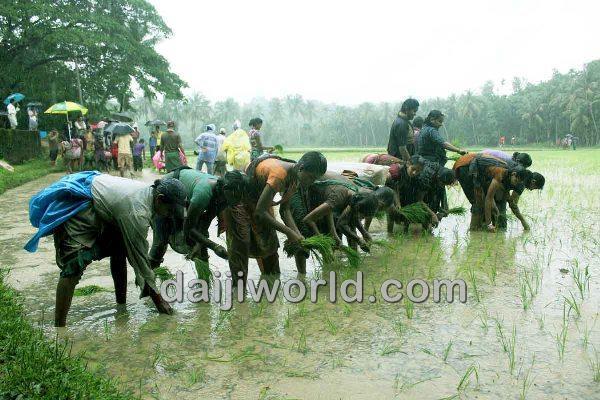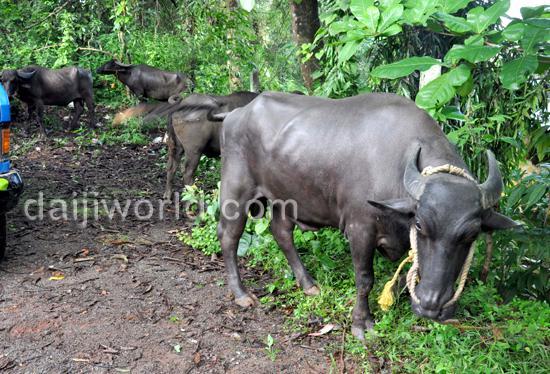The first image is the image on the left, the second image is the image on the right. Evaluate the accuracy of this statement regarding the images: "In one of the images, water buffalos are standing in muddy water.". Is it true? Answer yes or no. No. The first image is the image on the left, the second image is the image on the right. Given the left and right images, does the statement "Each image shows at least one man interacting with a team of two hitched oxen, and one image shows a man holding a stick behind oxen." hold true? Answer yes or no. No. 